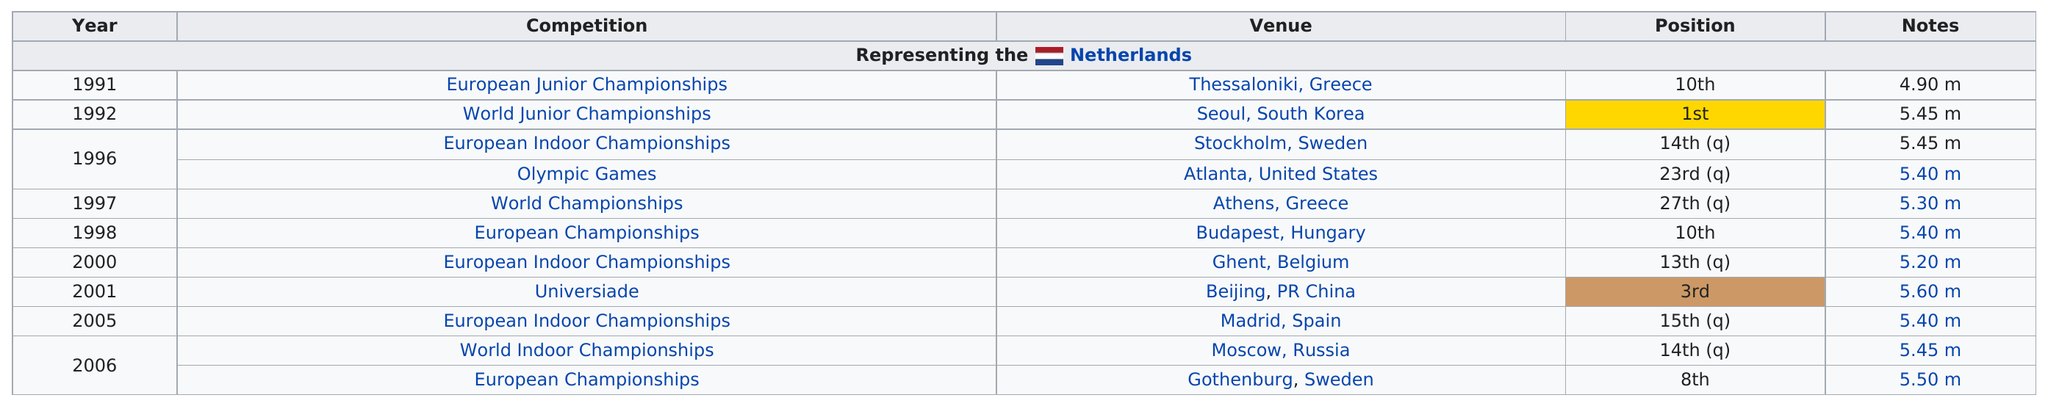Highlight a few significant elements in this photo. I'm sorry, but I'm having difficulty understanding the specific question you are asking. It appears to be a string of text with a question mark at the end. Could you please rephrase or provide more context for your question? The competitor competed in the European Junior Championships, which was their first competition. The only time this competitor achieved first place in competition was at the World Junior Championships, where they faced stiff competition. This competitor last competed in the European Championships, which took place recently. He finished in at least 10th place in 5 competitions. 